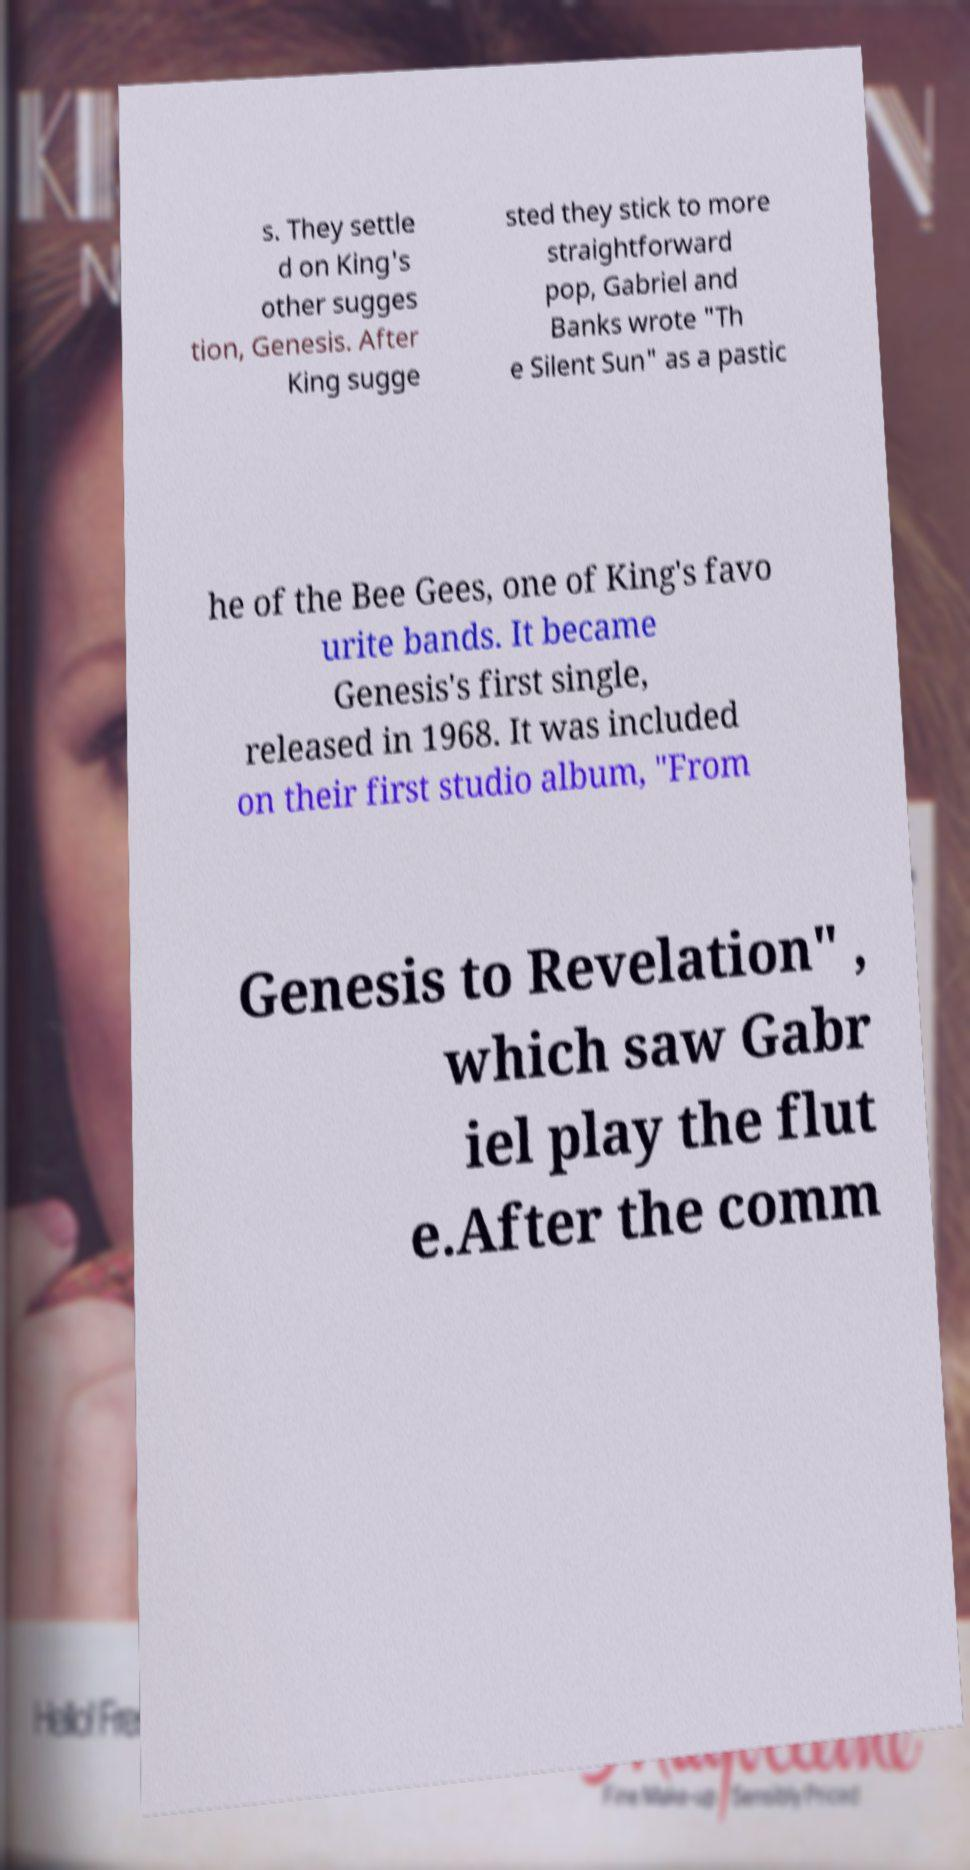There's text embedded in this image that I need extracted. Can you transcribe it verbatim? s. They settle d on King's other sugges tion, Genesis. After King sugge sted they stick to more straightforward pop, Gabriel and Banks wrote "Th e Silent Sun" as a pastic he of the Bee Gees, one of King's favo urite bands. It became Genesis's first single, released in 1968. It was included on their first studio album, "From Genesis to Revelation" , which saw Gabr iel play the flut e.After the comm 